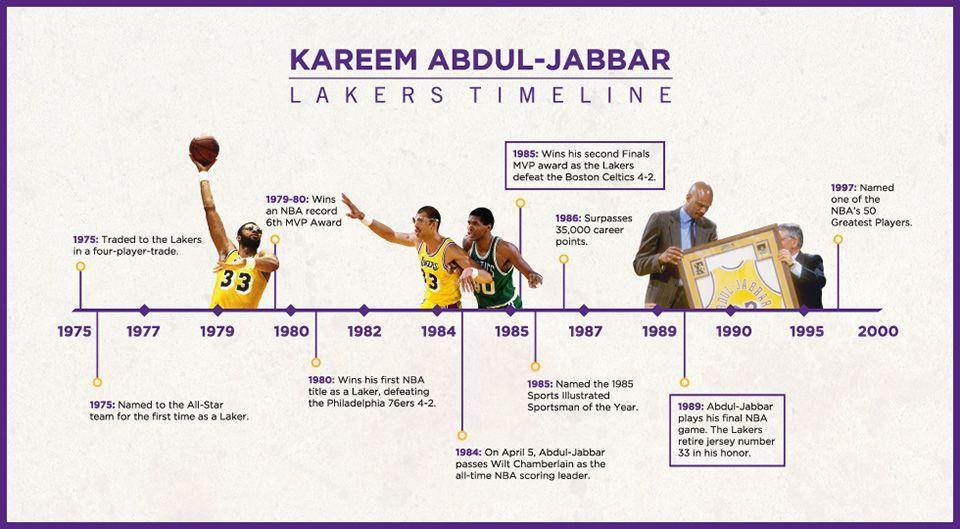When did Lakers retire jersey number 33
Answer the question with a short phrase. 1989 What was the jersey number of Kareen Abdu-Jabbar 33 When did Kareen Abdul Jabbar join Lakers 1975 How many achievements from 1985 to 2000 have been highlighted 5 